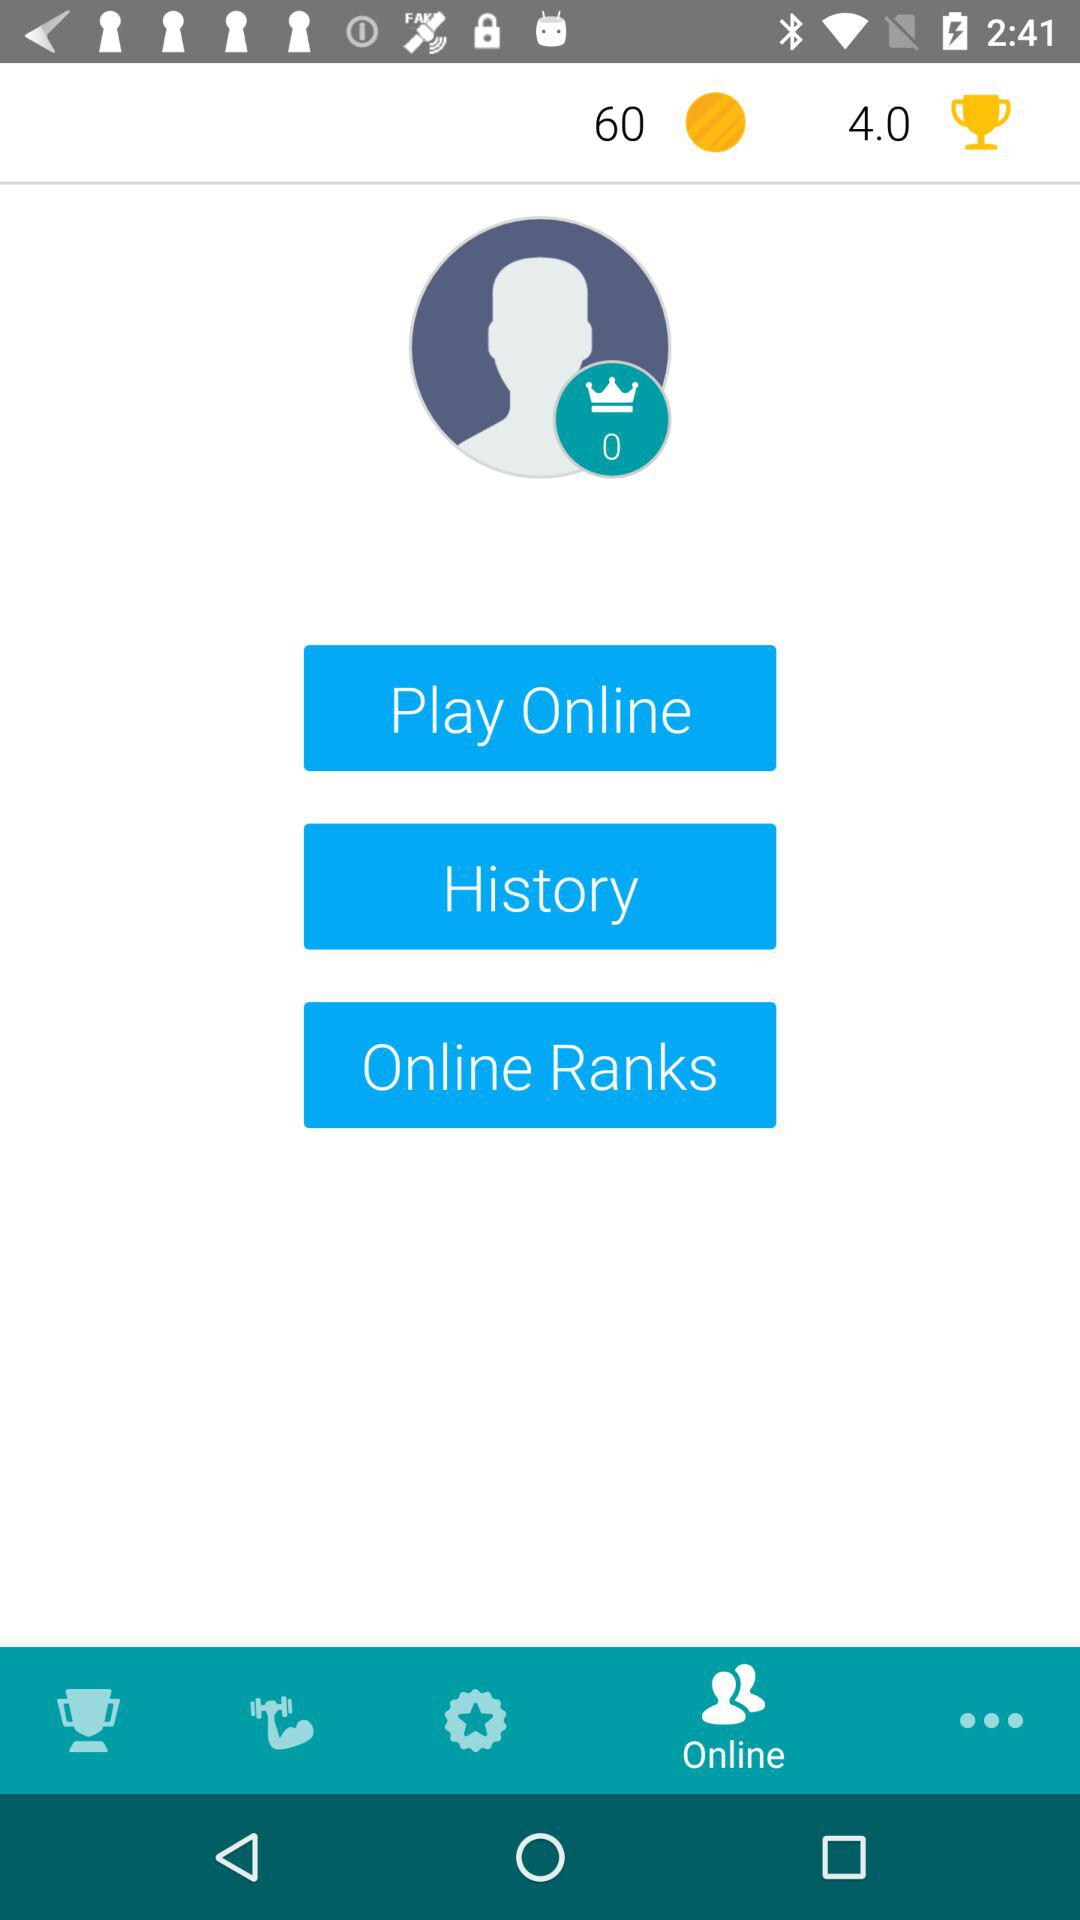How many trophies are given? There are 4.0 trophies given. 